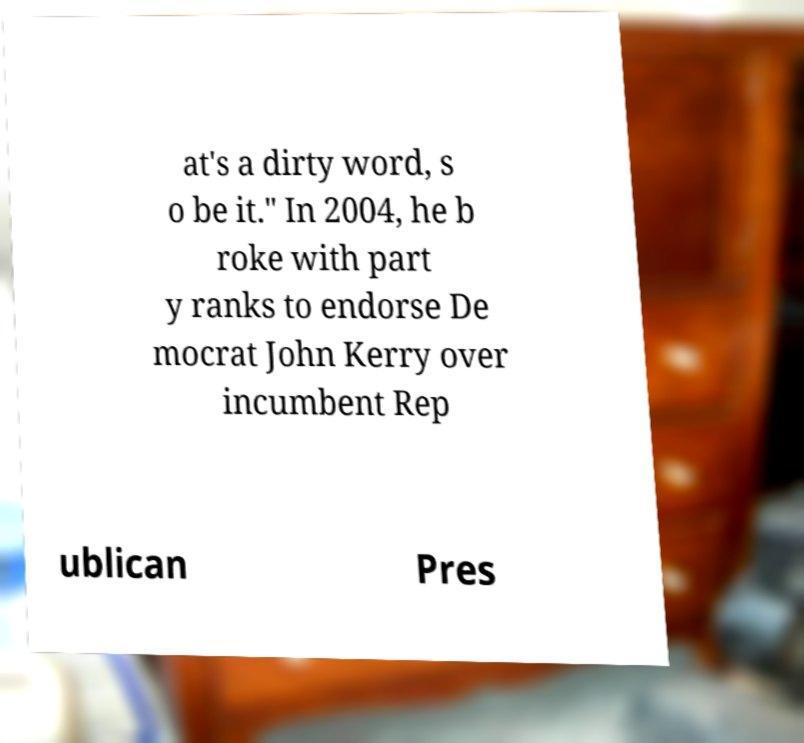Could you assist in decoding the text presented in this image and type it out clearly? at's a dirty word, s o be it." In 2004, he b roke with part y ranks to endorse De mocrat John Kerry over incumbent Rep ublican Pres 